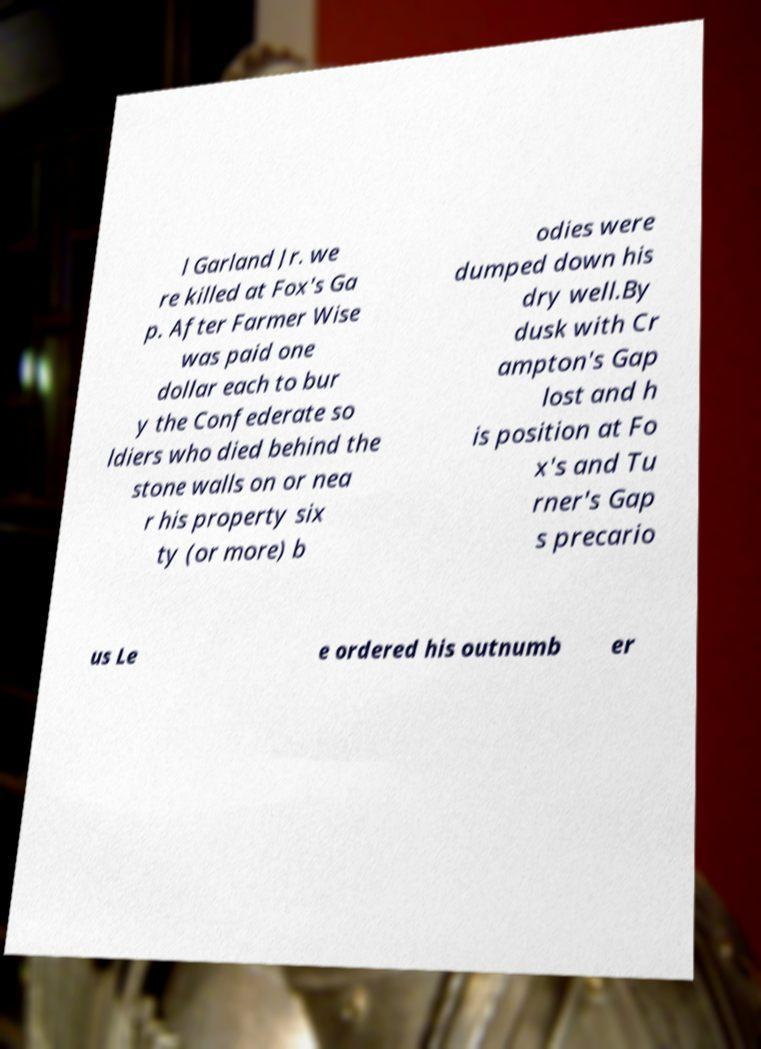Please read and relay the text visible in this image. What does it say? l Garland Jr. we re killed at Fox's Ga p. After Farmer Wise was paid one dollar each to bur y the Confederate so ldiers who died behind the stone walls on or nea r his property six ty (or more) b odies were dumped down his dry well.By dusk with Cr ampton's Gap lost and h is position at Fo x's and Tu rner's Gap s precario us Le e ordered his outnumb er 